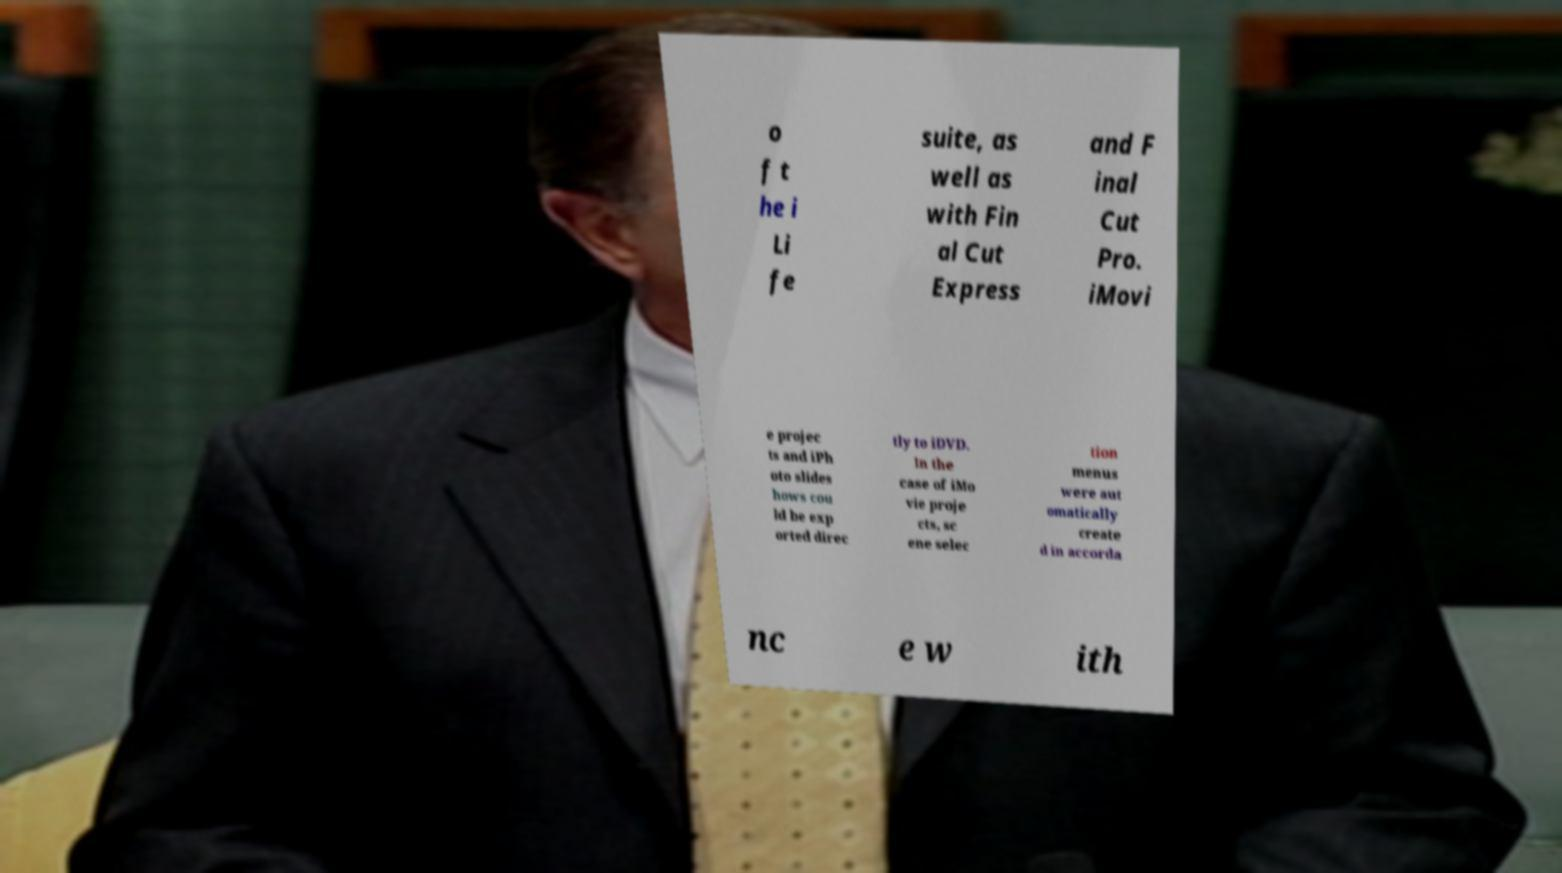Could you extract and type out the text from this image? o f t he i Li fe suite, as well as with Fin al Cut Express and F inal Cut Pro. iMovi e projec ts and iPh oto slides hows cou ld be exp orted direc tly to iDVD. In the case of iMo vie proje cts, sc ene selec tion menus were aut omatically create d in accorda nc e w ith 